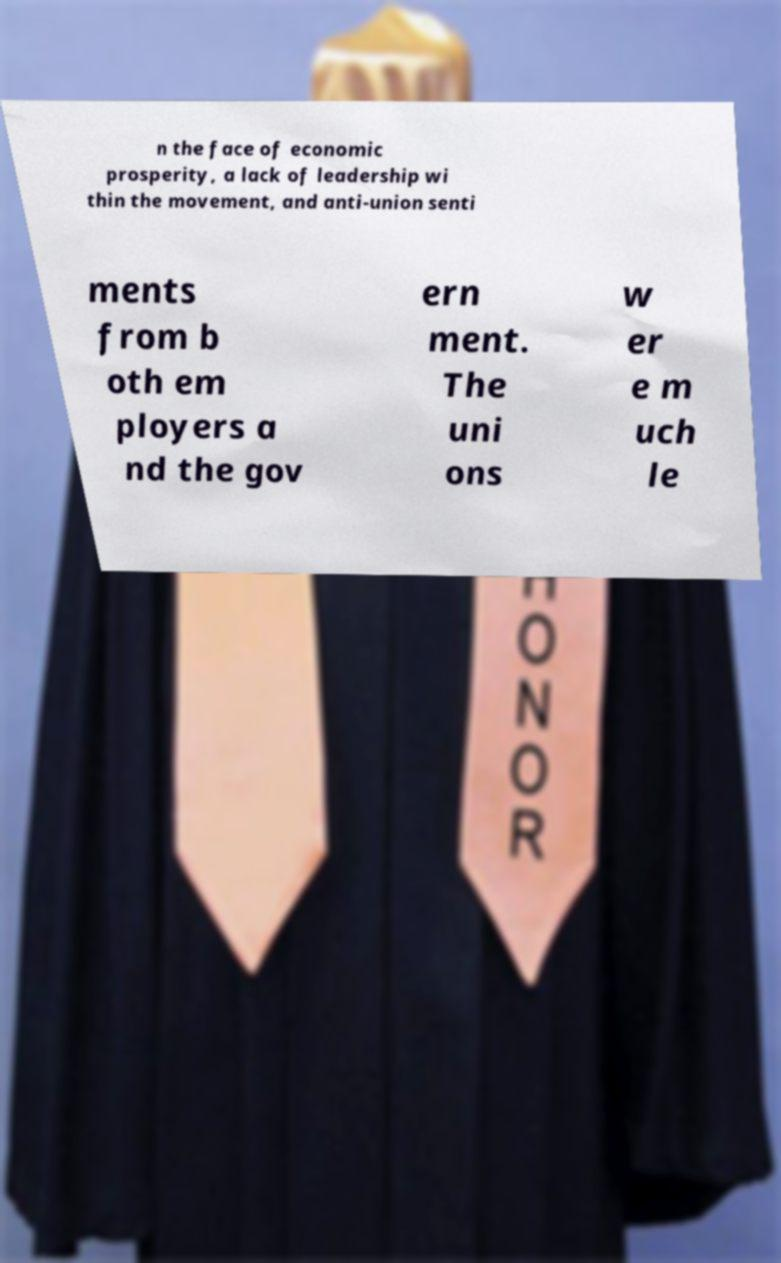Could you assist in decoding the text presented in this image and type it out clearly? n the face of economic prosperity, a lack of leadership wi thin the movement, and anti-union senti ments from b oth em ployers a nd the gov ern ment. The uni ons w er e m uch le 